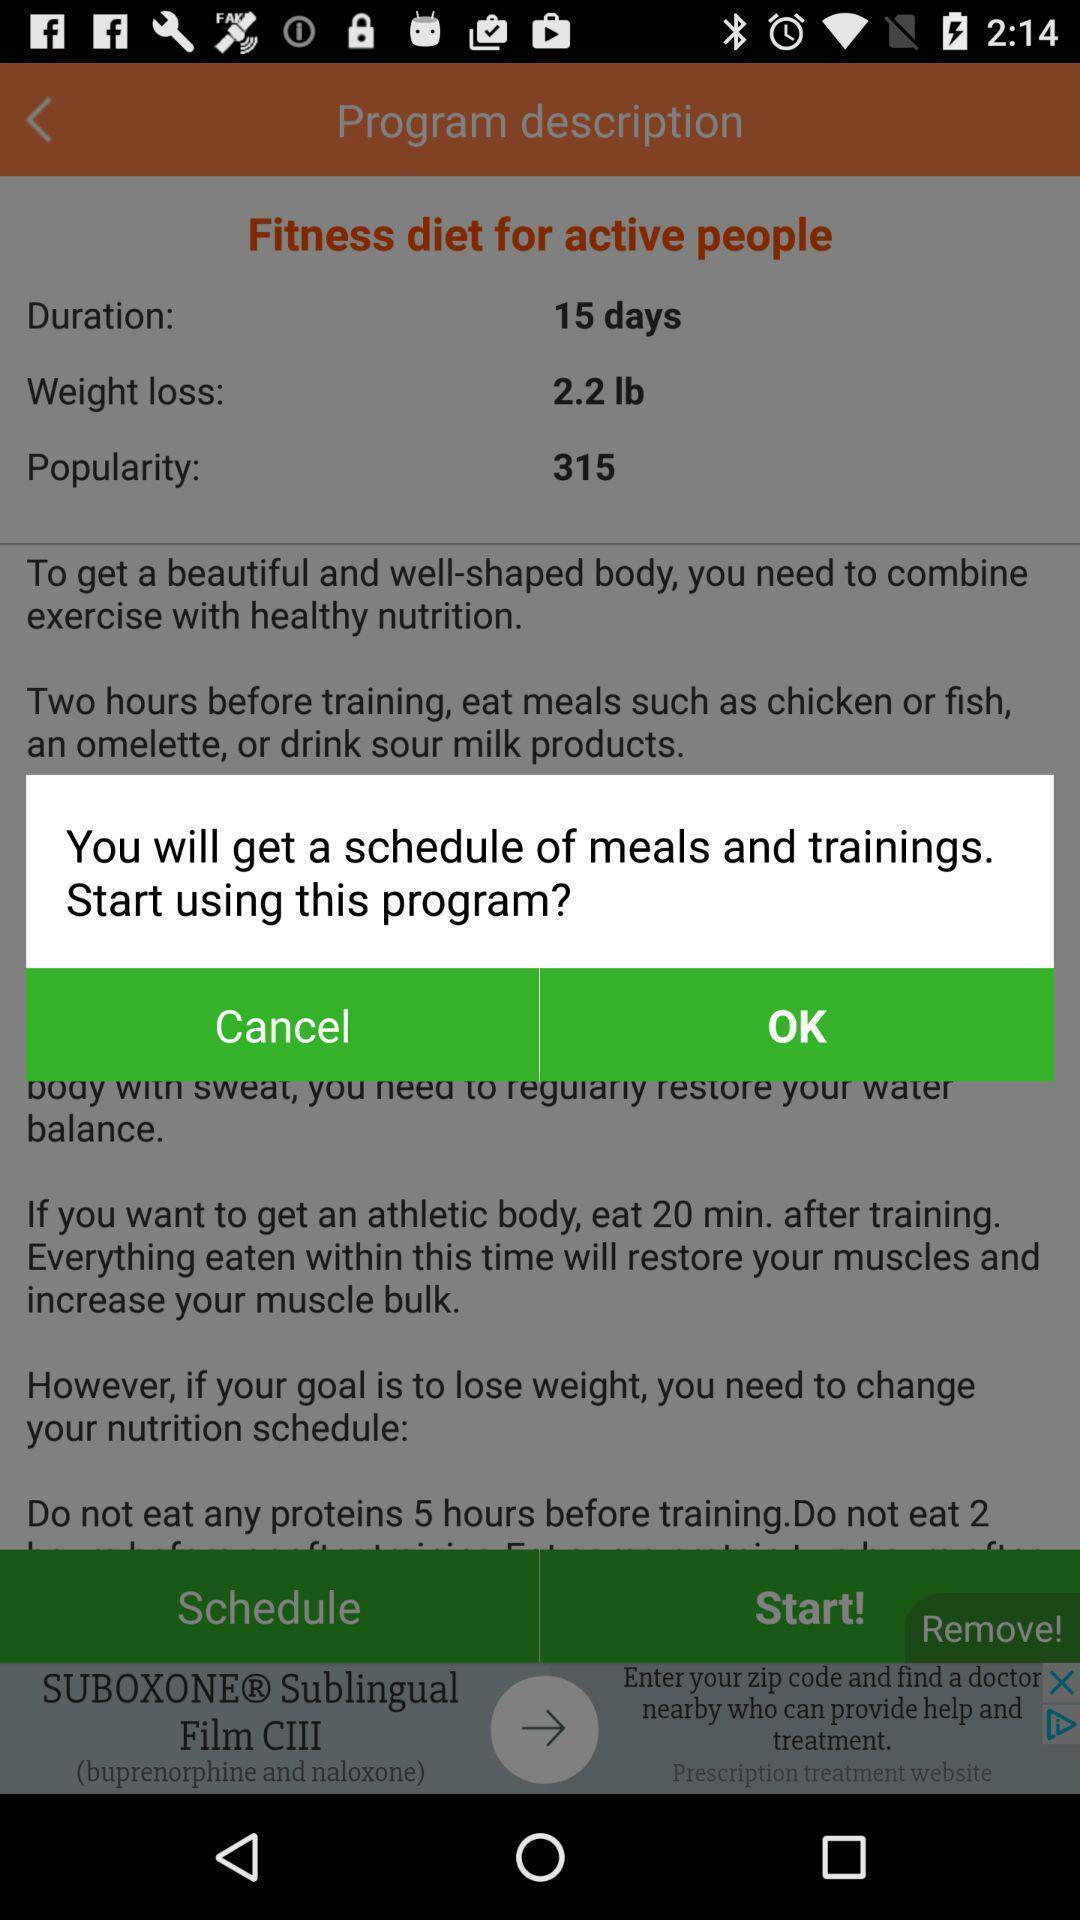Summarize the main components in this picture. Popup displaying schedule information about health diet application. 